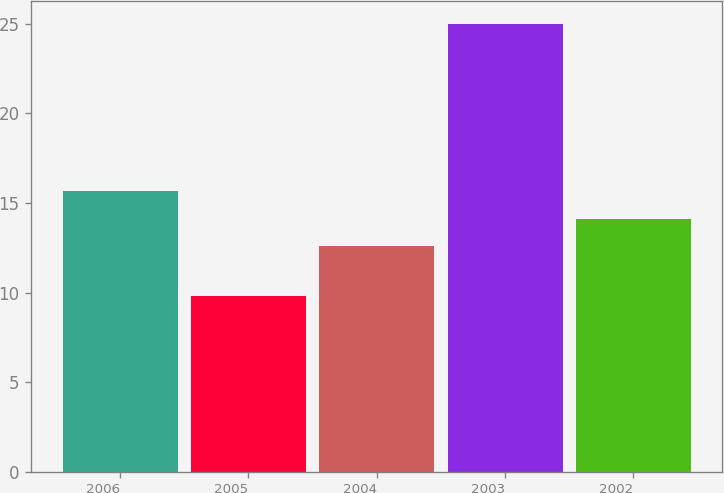Convert chart to OTSL. <chart><loc_0><loc_0><loc_500><loc_500><bar_chart><fcel>2006<fcel>2005<fcel>2004<fcel>2003<fcel>2002<nl><fcel>15.64<fcel>9.8<fcel>12.6<fcel>25<fcel>14.12<nl></chart> 